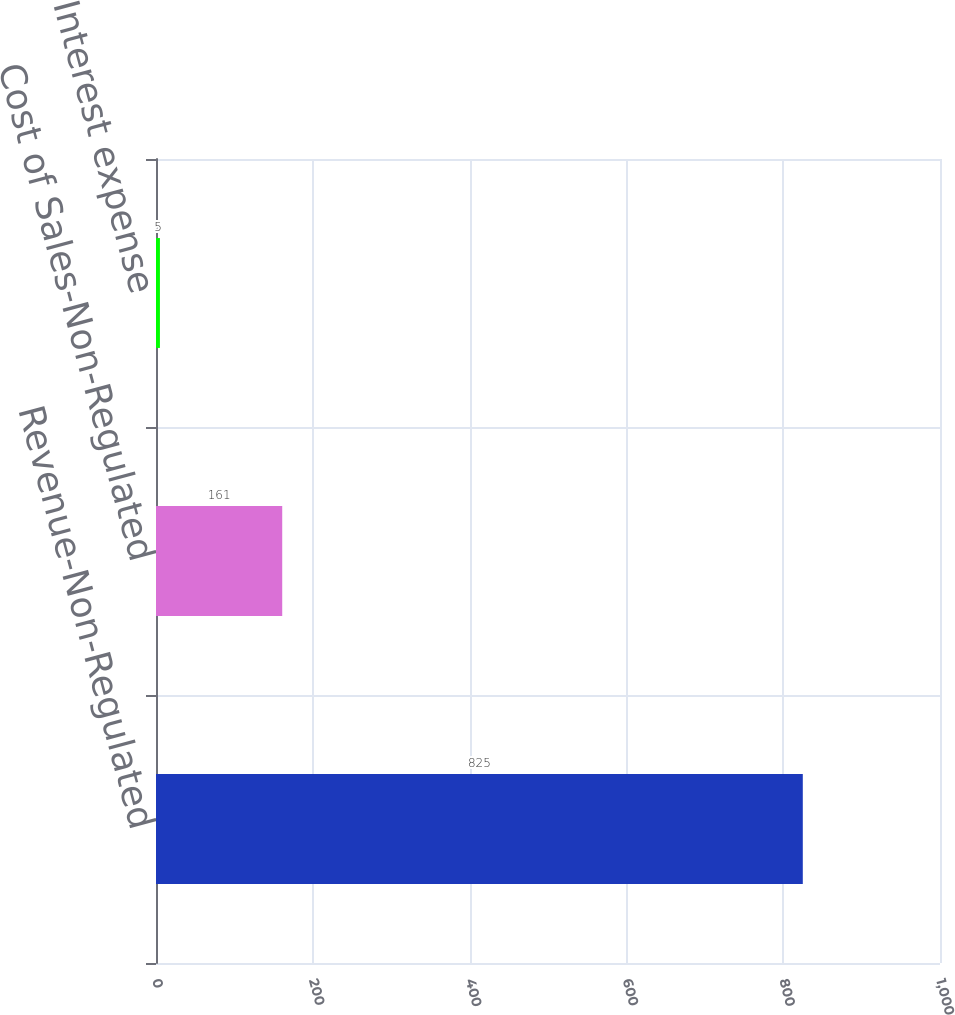Convert chart to OTSL. <chart><loc_0><loc_0><loc_500><loc_500><bar_chart><fcel>Revenue-Non-Regulated<fcel>Cost of Sales-Non-Regulated<fcel>Interest expense<nl><fcel>825<fcel>161<fcel>5<nl></chart> 